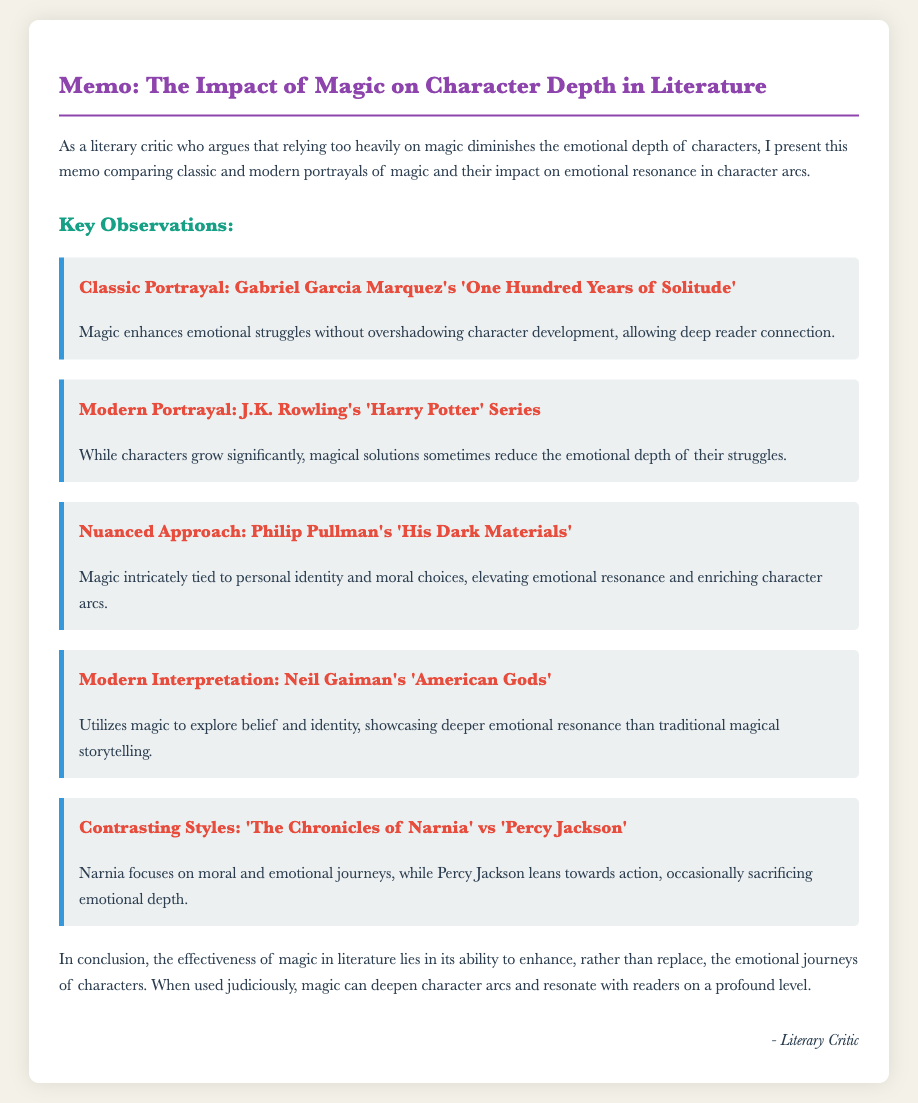What is the title of the memo? The title of the memo is provided in the header section of the document.
Answer: The Impact of Magic on Character Depth in Literature Who is the author of the memo? The author is mentioned at the end of the document in the signature section.
Answer: Literary Critic What classic work is referenced in the memo? The memo includes references to various literary works; the classic one is explicitly mentioned.
Answer: One Hundred Years of Solitude Which modern series is critiqued for reducing emotional depth? The memo discusses a modern series that sometimes reduces character struggles through magical solutions.
Answer: Harry Potter What does Philip Pullman’s work tie magic to? The character of Pullman’s work highlights a specific relationship between magic and personal aspects.
Answer: Personal identity and moral choices How many contrasting styles are compared in the memo? The document presents a comparative analysis of two distinct works in literature.
Answer: Two What does the document conclude about the use of magic? The memo concludes with an overarching statement about the effectiveness of magic in literature.
Answer: Enhance, rather than replace What impact does 'Narnia' focus on? The document mentions an area of emphasis for the classic 'Narnia' work, which is essential to its narrative.
Answer: Moral and emotional journeys What is the primary theme of Neil Gaiman's 'American Gods'? The reaction of the work is explored through a particular thematic lens mentioned in the memo.
Answer: Belief and identity What is the memo's primary concern about magic? The critique focuses on the perceived emotional implication of magic within literary narratives.
Answer: Diminishes the emotional depth of characters 